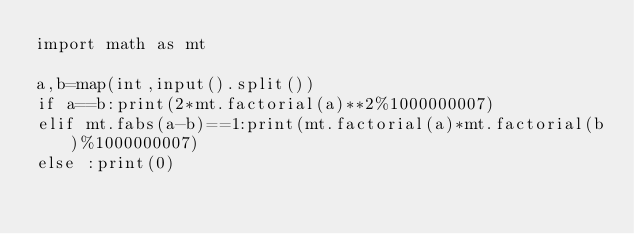<code> <loc_0><loc_0><loc_500><loc_500><_Python_>import math as mt

a,b=map(int,input().split())
if a==b:print(2*mt.factorial(a)**2%1000000007)
elif mt.fabs(a-b)==1:print(mt.factorial(a)*mt.factorial(b)%1000000007)
else :print(0)
</code> 